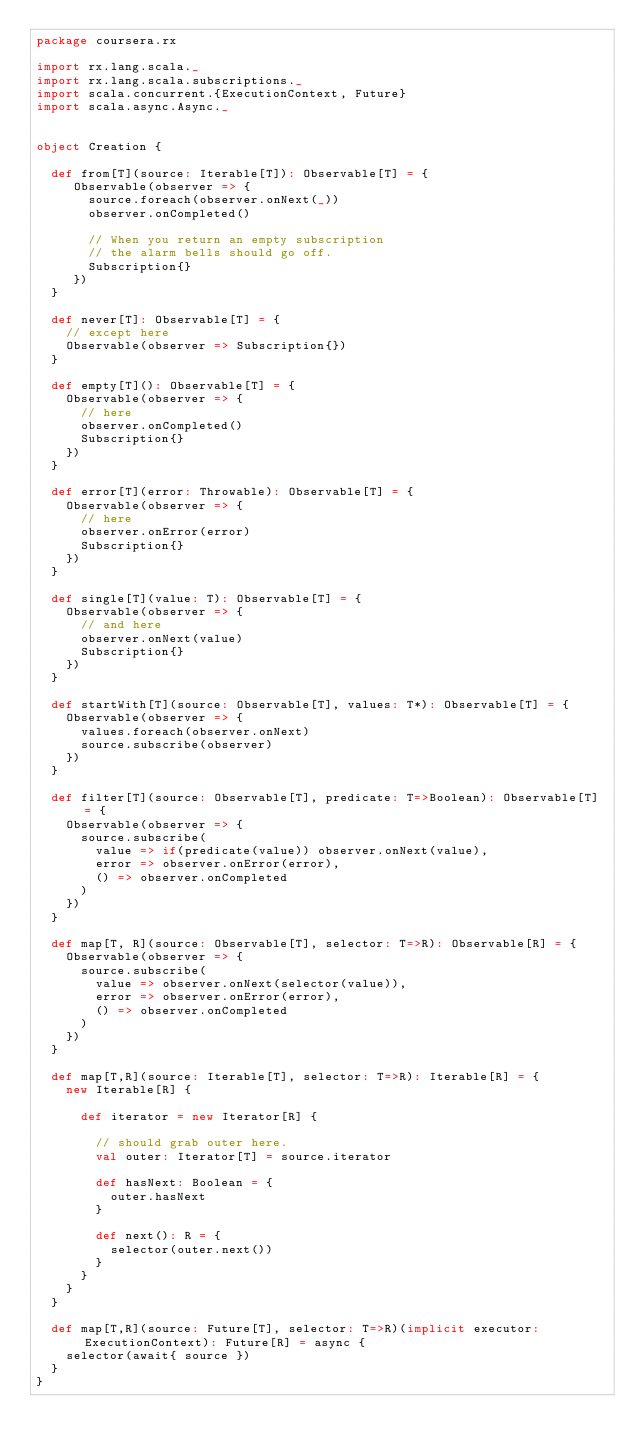<code> <loc_0><loc_0><loc_500><loc_500><_Scala_>package coursera.rx

import rx.lang.scala._
import rx.lang.scala.subscriptions._
import scala.concurrent.{ExecutionContext, Future}
import scala.async.Async._


object Creation {

  def from[T](source: Iterable[T]): Observable[T] = {
     Observable(observer => {
       source.foreach(observer.onNext(_))
       observer.onCompleted()

       // When you return an empty subscription
       // the alarm bells should go off.
       Subscription{}
     })
  }

  def never[T]: Observable[T] = {
    // except here
    Observable(observer => Subscription{})
  }

  def empty[T](): Observable[T] = {
    Observable(observer => {
      // here
      observer.onCompleted()
      Subscription{}
    })
  }

  def error[T](error: Throwable): Observable[T] = {
    Observable(observer => {
      // here
      observer.onError(error)
      Subscription{}
    })
  }

  def single[T](value: T): Observable[T] = {
    Observable(observer => {
      // and here
      observer.onNext(value)
      Subscription{}
    })
  }

  def startWith[T](source: Observable[T], values: T*): Observable[T] = {
    Observable(observer => {
      values.foreach(observer.onNext)
      source.subscribe(observer)
    })
  }

  def filter[T](source: Observable[T], predicate: T=>Boolean): Observable[T] = {
    Observable(observer => {
      source.subscribe(
        value => if(predicate(value)) observer.onNext(value),
        error => observer.onError(error),
        () => observer.onCompleted
      )
    })
  }

  def map[T, R](source: Observable[T], selector: T=>R): Observable[R] = {
    Observable(observer => {
      source.subscribe(
        value => observer.onNext(selector(value)),
        error => observer.onError(error),
        () => observer.onCompleted
      )
    })
  }

  def map[T,R](source: Iterable[T], selector: T=>R): Iterable[R] = {
    new Iterable[R] {

      def iterator = new Iterator[R] {

        // should grab outer here.
        val outer: Iterator[T] = source.iterator

        def hasNext: Boolean = {
          outer.hasNext
        }

        def next(): R = {
          selector(outer.next())
        }
      }
    }
  }

  def map[T,R](source: Future[T], selector: T=>R)(implicit executor: ExecutionContext): Future[R] = async {
    selector(await{ source })
  }
}
</code> 